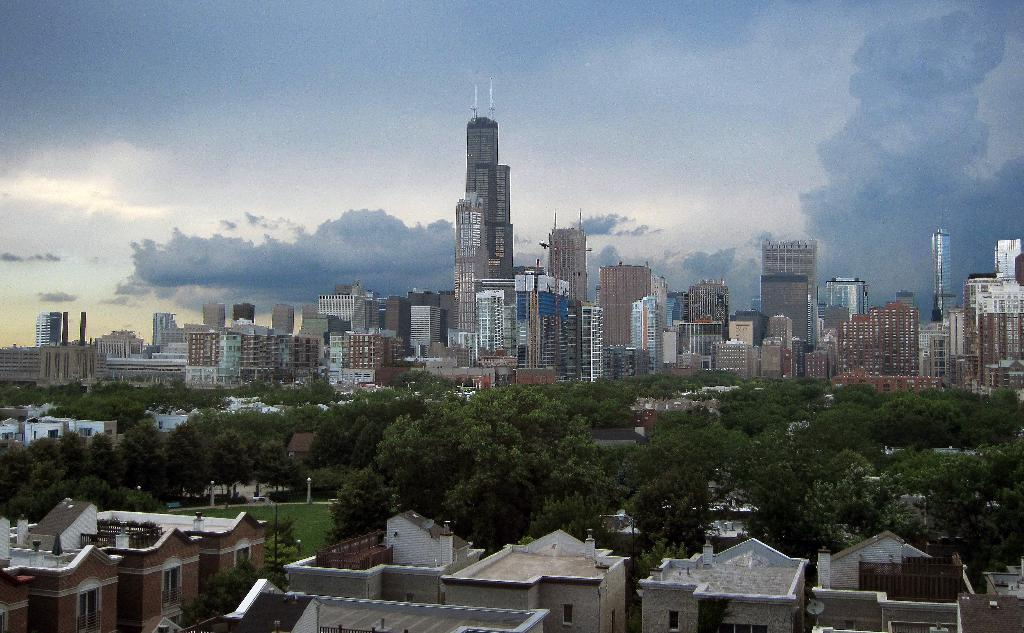What type of structures can be seen in the image? There are buildings in the image. What type of vegetation is present in the image? There are trees in the image. What is covering the ground in the image? There is grass on the ground in the image. What is the condition of the sky in the image? The sky is cloudy in the image. What type of apparel is hanging on the pot in the image? There is no pot or apparel present in the image. What season is depicted in the image? The provided facts do not mention any specific season, so it cannot be determined from the image. 